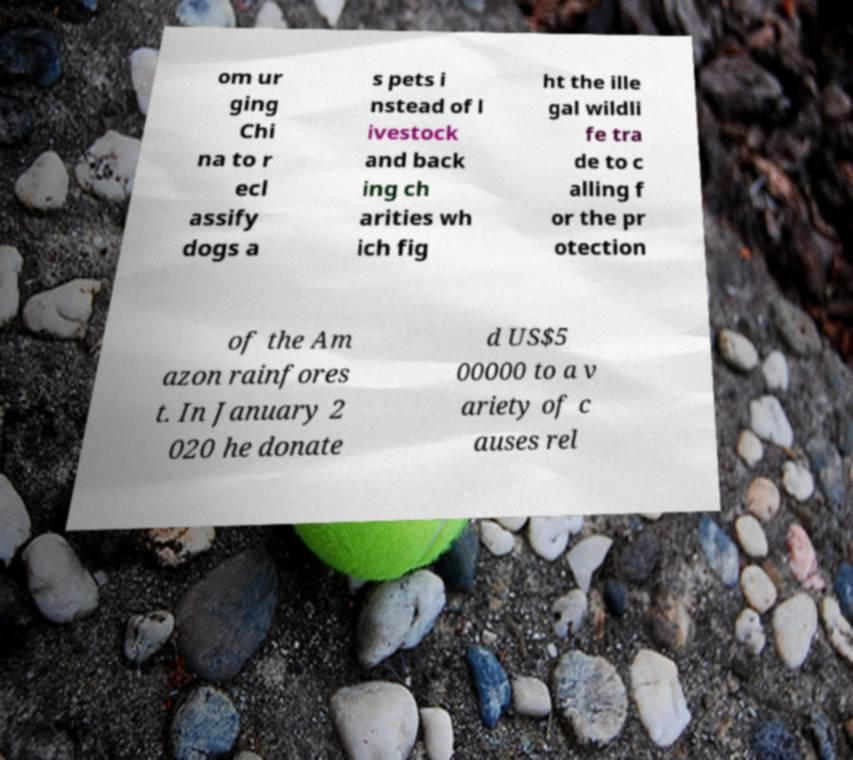What messages or text are displayed in this image? I need them in a readable, typed format. om ur ging Chi na to r ecl assify dogs a s pets i nstead of l ivestock and back ing ch arities wh ich fig ht the ille gal wildli fe tra de to c alling f or the pr otection of the Am azon rainfores t. In January 2 020 he donate d US$5 00000 to a v ariety of c auses rel 